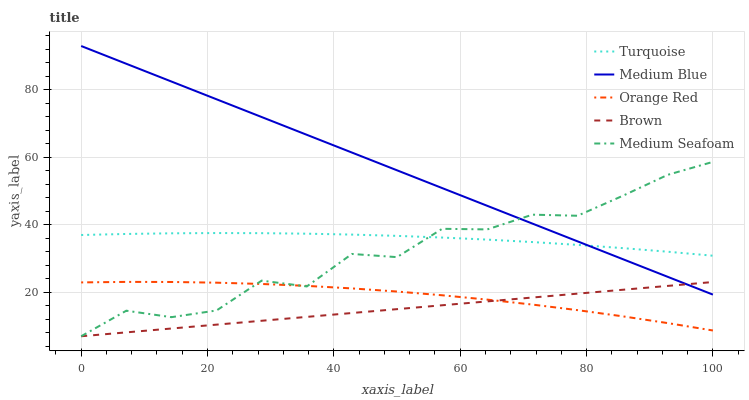Does Brown have the minimum area under the curve?
Answer yes or no. Yes. Does Medium Blue have the maximum area under the curve?
Answer yes or no. Yes. Does Turquoise have the minimum area under the curve?
Answer yes or no. No. Does Turquoise have the maximum area under the curve?
Answer yes or no. No. Is Brown the smoothest?
Answer yes or no. Yes. Is Medium Seafoam the roughest?
Answer yes or no. Yes. Is Turquoise the smoothest?
Answer yes or no. No. Is Turquoise the roughest?
Answer yes or no. No. Does Brown have the lowest value?
Answer yes or no. Yes. Does Medium Blue have the lowest value?
Answer yes or no. No. Does Medium Blue have the highest value?
Answer yes or no. Yes. Does Turquoise have the highest value?
Answer yes or no. No. Is Orange Red less than Medium Blue?
Answer yes or no. Yes. Is Turquoise greater than Orange Red?
Answer yes or no. Yes. Does Medium Blue intersect Medium Seafoam?
Answer yes or no. Yes. Is Medium Blue less than Medium Seafoam?
Answer yes or no. No. Is Medium Blue greater than Medium Seafoam?
Answer yes or no. No. Does Orange Red intersect Medium Blue?
Answer yes or no. No. 